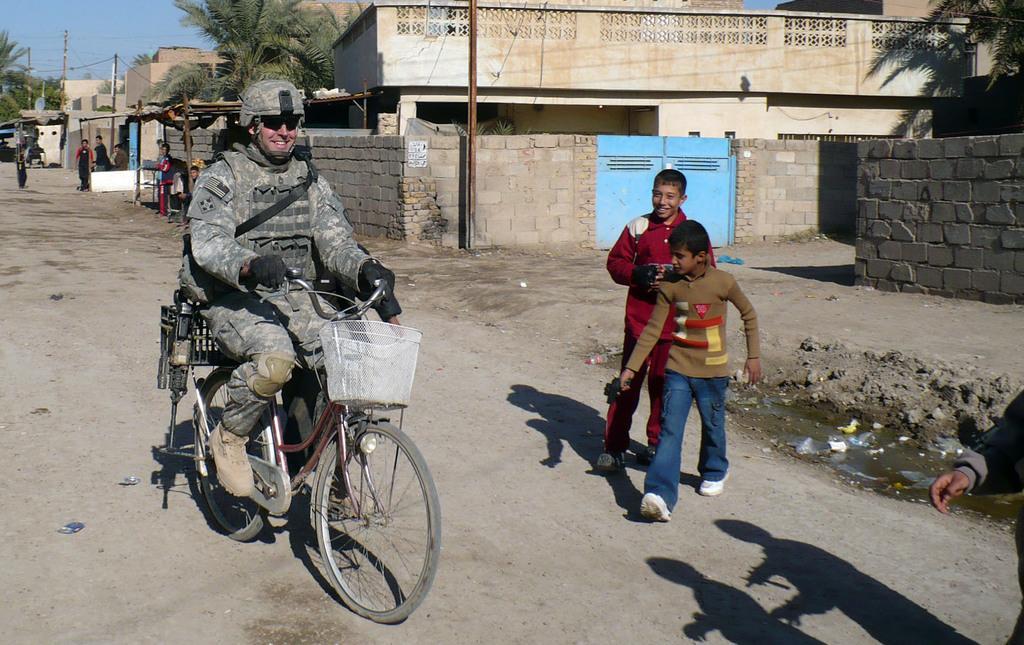How would you summarize this image in a sentence or two? A military person is riding bicycle,on the right two boys are walking in the road. In the background there are trees,buildings,pole,few people and sky. 